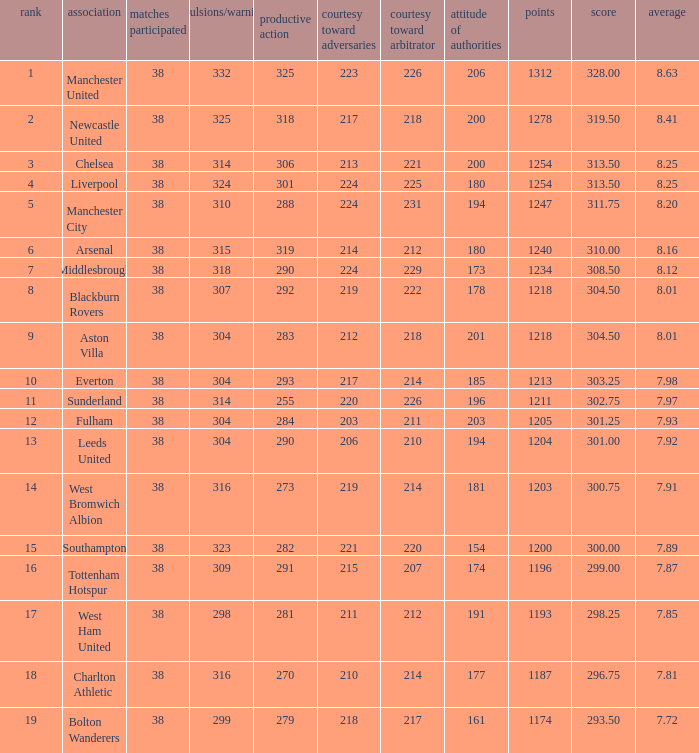Name the points for 212 respect toward opponents 1218.0. 